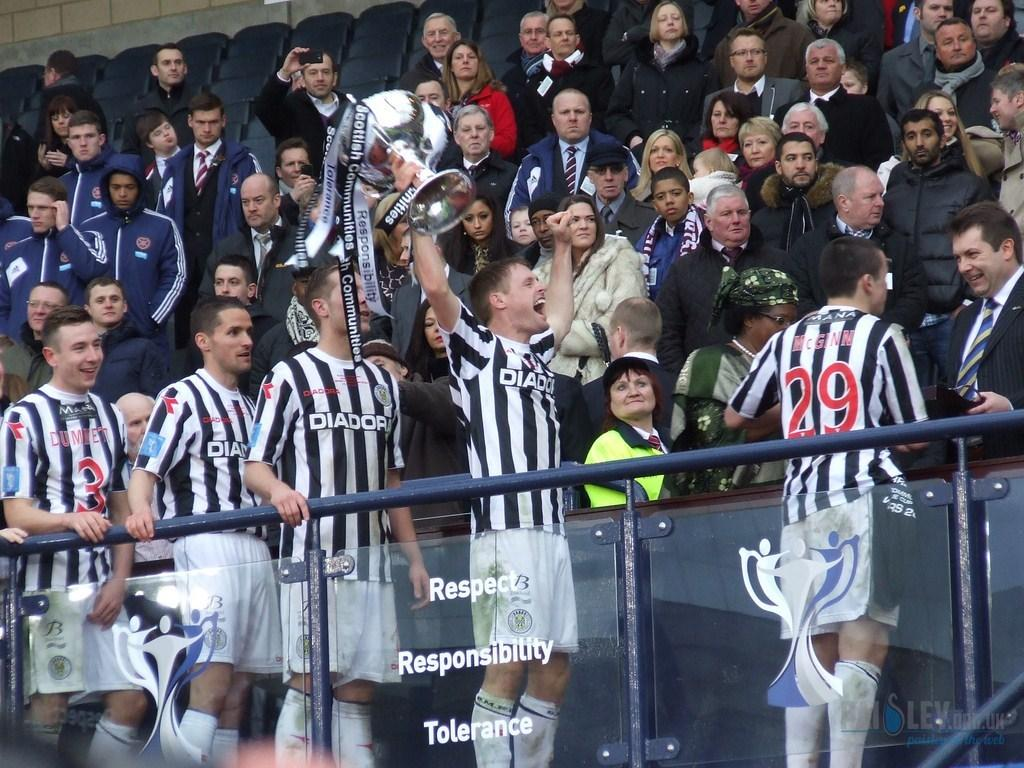<image>
Write a terse but informative summary of the picture. Many boys from Diador are standing in front of a large crowd 